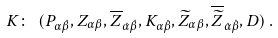<formula> <loc_0><loc_0><loc_500><loc_500>K \colon \ ( P _ { \alpha \dot { \beta } } , Z _ { \alpha \beta } , { \overline { Z } } _ { \dot { \alpha } \dot { \beta } } , K _ { { \alpha } \dot { \beta } } , { \widetilde { Z } } _ { { \alpha } { \beta } } , { \overline { { \widetilde { Z } } } } _ { \dot { \alpha } \dot { \beta } } , D ) \, .</formula> 